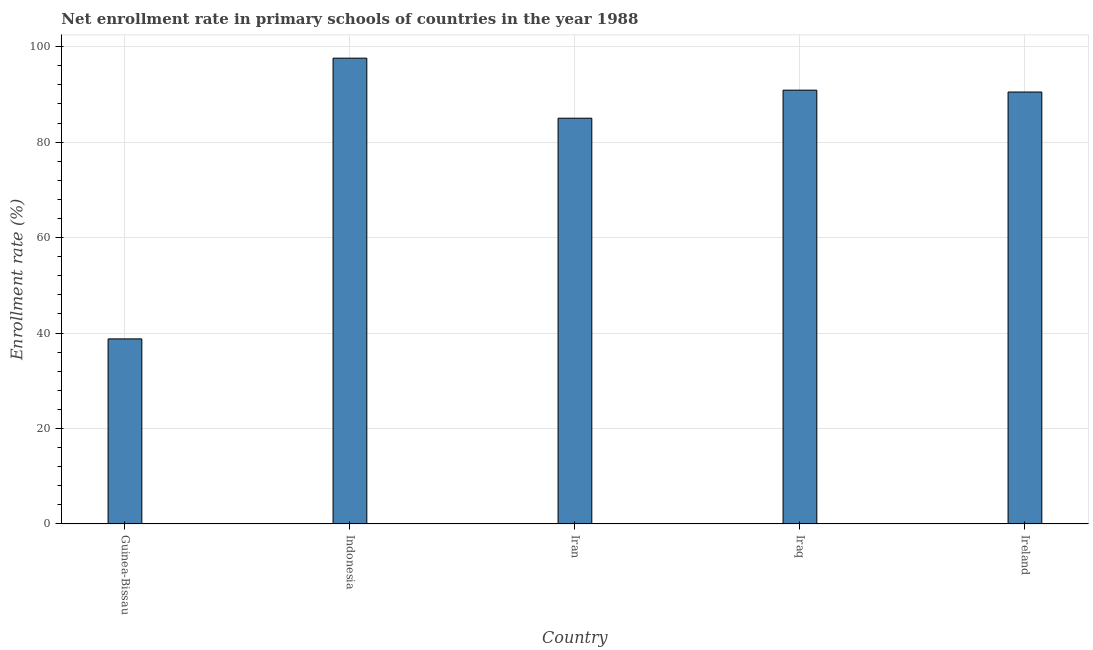Does the graph contain any zero values?
Make the answer very short. No. What is the title of the graph?
Give a very brief answer. Net enrollment rate in primary schools of countries in the year 1988. What is the label or title of the Y-axis?
Offer a very short reply. Enrollment rate (%). What is the net enrollment rate in primary schools in Guinea-Bissau?
Your response must be concise. 38.78. Across all countries, what is the maximum net enrollment rate in primary schools?
Your response must be concise. 97.59. Across all countries, what is the minimum net enrollment rate in primary schools?
Make the answer very short. 38.78. In which country was the net enrollment rate in primary schools minimum?
Offer a terse response. Guinea-Bissau. What is the sum of the net enrollment rate in primary schools?
Make the answer very short. 402.76. What is the difference between the net enrollment rate in primary schools in Indonesia and Iraq?
Ensure brevity in your answer.  6.71. What is the average net enrollment rate in primary schools per country?
Provide a succinct answer. 80.55. What is the median net enrollment rate in primary schools?
Give a very brief answer. 90.5. What is the ratio of the net enrollment rate in primary schools in Indonesia to that in Iraq?
Make the answer very short. 1.07. What is the difference between the highest and the second highest net enrollment rate in primary schools?
Your answer should be compact. 6.71. What is the difference between the highest and the lowest net enrollment rate in primary schools?
Your response must be concise. 58.81. In how many countries, is the net enrollment rate in primary schools greater than the average net enrollment rate in primary schools taken over all countries?
Your answer should be very brief. 4. How many bars are there?
Your response must be concise. 5. How many countries are there in the graph?
Offer a very short reply. 5. What is the difference between two consecutive major ticks on the Y-axis?
Your response must be concise. 20. Are the values on the major ticks of Y-axis written in scientific E-notation?
Offer a terse response. No. What is the Enrollment rate (%) of Guinea-Bissau?
Ensure brevity in your answer.  38.78. What is the Enrollment rate (%) in Indonesia?
Offer a very short reply. 97.59. What is the Enrollment rate (%) in Iran?
Offer a very short reply. 85.01. What is the Enrollment rate (%) in Iraq?
Your response must be concise. 90.89. What is the Enrollment rate (%) in Ireland?
Make the answer very short. 90.5. What is the difference between the Enrollment rate (%) in Guinea-Bissau and Indonesia?
Your response must be concise. -58.81. What is the difference between the Enrollment rate (%) in Guinea-Bissau and Iran?
Give a very brief answer. -46.23. What is the difference between the Enrollment rate (%) in Guinea-Bissau and Iraq?
Ensure brevity in your answer.  -52.11. What is the difference between the Enrollment rate (%) in Guinea-Bissau and Ireland?
Ensure brevity in your answer.  -51.72. What is the difference between the Enrollment rate (%) in Indonesia and Iran?
Give a very brief answer. 12.58. What is the difference between the Enrollment rate (%) in Indonesia and Iraq?
Offer a very short reply. 6.7. What is the difference between the Enrollment rate (%) in Indonesia and Ireland?
Provide a succinct answer. 7.09. What is the difference between the Enrollment rate (%) in Iran and Iraq?
Provide a succinct answer. -5.88. What is the difference between the Enrollment rate (%) in Iran and Ireland?
Give a very brief answer. -5.49. What is the difference between the Enrollment rate (%) in Iraq and Ireland?
Keep it short and to the point. 0.39. What is the ratio of the Enrollment rate (%) in Guinea-Bissau to that in Indonesia?
Make the answer very short. 0.4. What is the ratio of the Enrollment rate (%) in Guinea-Bissau to that in Iran?
Offer a terse response. 0.46. What is the ratio of the Enrollment rate (%) in Guinea-Bissau to that in Iraq?
Ensure brevity in your answer.  0.43. What is the ratio of the Enrollment rate (%) in Guinea-Bissau to that in Ireland?
Give a very brief answer. 0.43. What is the ratio of the Enrollment rate (%) in Indonesia to that in Iran?
Make the answer very short. 1.15. What is the ratio of the Enrollment rate (%) in Indonesia to that in Iraq?
Your response must be concise. 1.07. What is the ratio of the Enrollment rate (%) in Indonesia to that in Ireland?
Make the answer very short. 1.08. What is the ratio of the Enrollment rate (%) in Iran to that in Iraq?
Provide a succinct answer. 0.94. What is the ratio of the Enrollment rate (%) in Iran to that in Ireland?
Offer a terse response. 0.94. What is the ratio of the Enrollment rate (%) in Iraq to that in Ireland?
Offer a terse response. 1. 